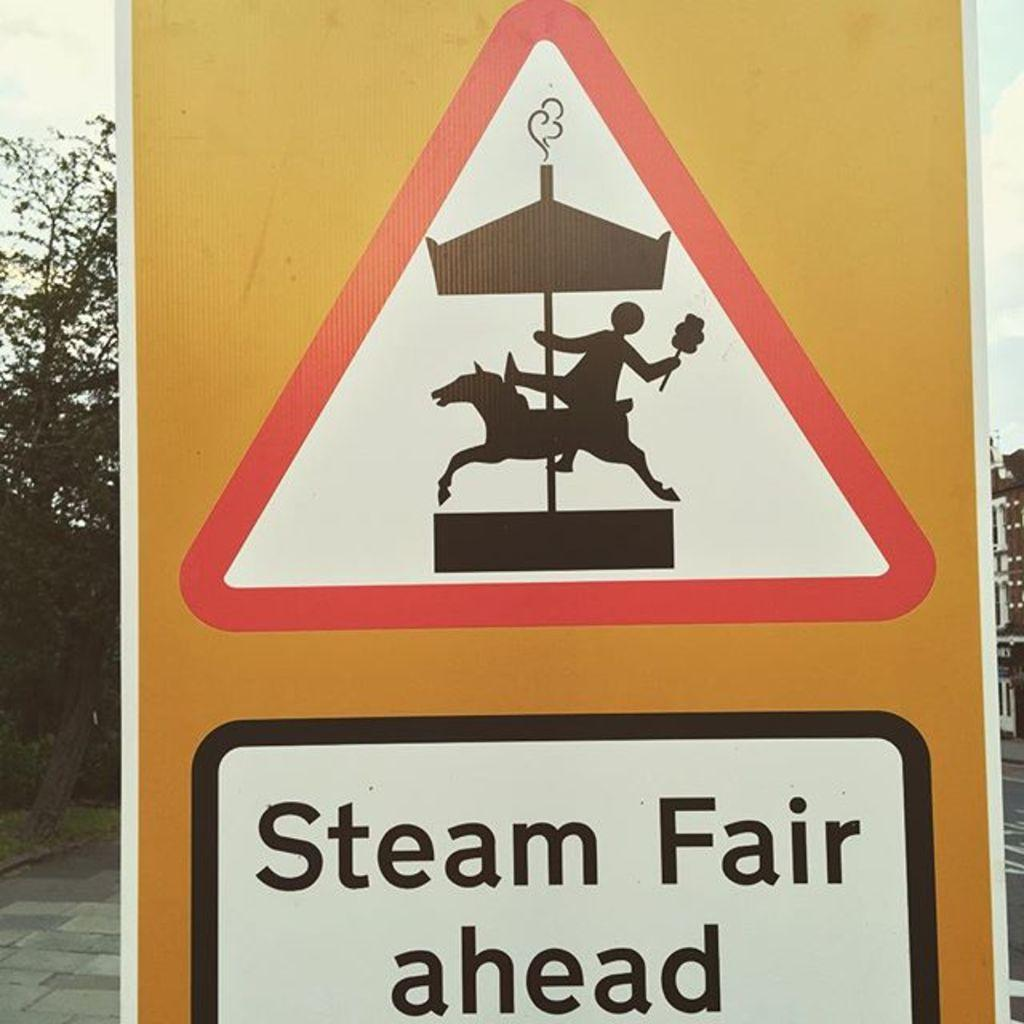<image>
Describe the image concisely. A yellow sign shows a carousel and reads "Steam Fair Ahead". 